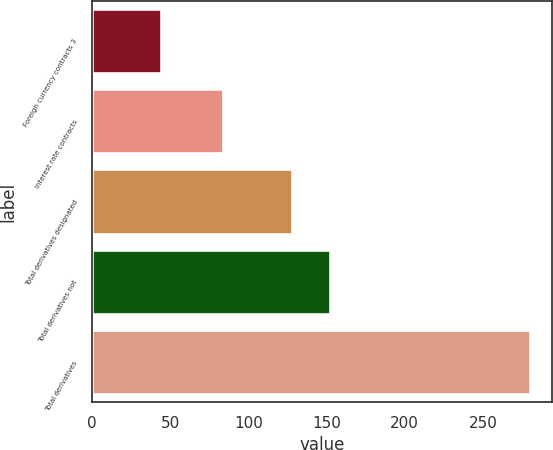Convert chart to OTSL. <chart><loc_0><loc_0><loc_500><loc_500><bar_chart><fcel>Foreign currency contracts 3<fcel>Interest rate contracts<fcel>Total derivatives designated<fcel>Total derivatives not<fcel>Total derivatives<nl><fcel>44<fcel>84<fcel>128<fcel>152<fcel>280<nl></chart> 